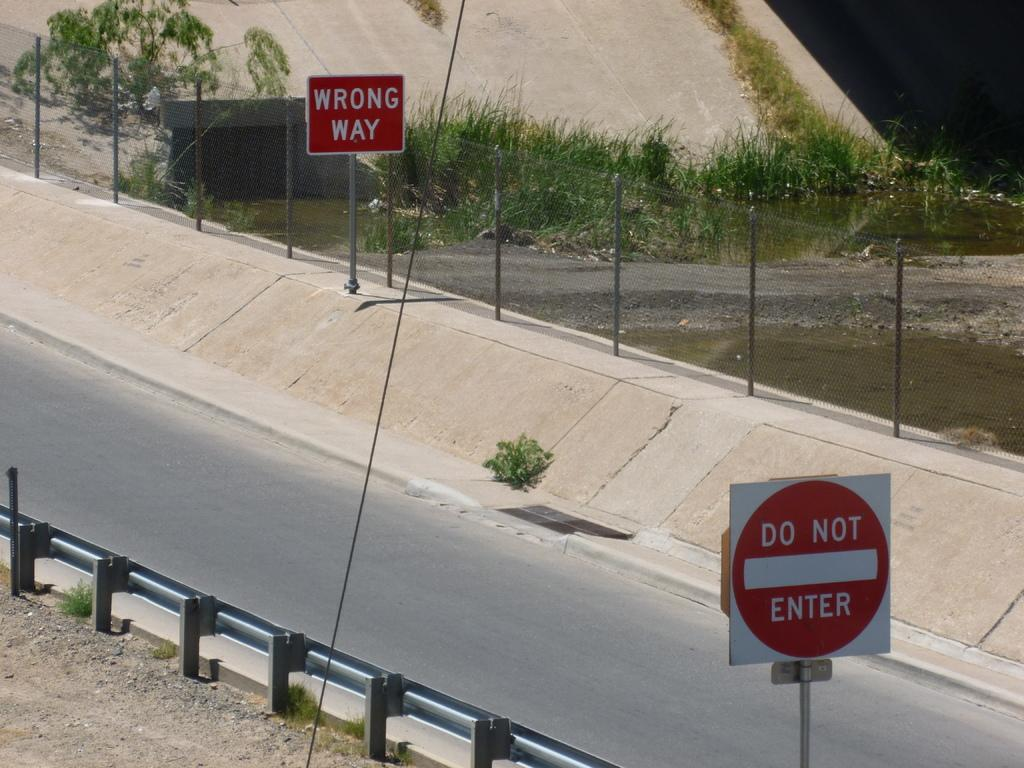Provide a one-sentence caption for the provided image. Highway with a wrong way sign and do not enter sign. 